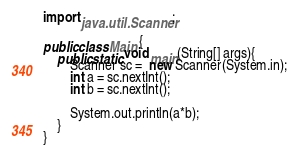<code> <loc_0><loc_0><loc_500><loc_500><_Java_>import java.util.Scanner;

public class Main {
    public static void main(String[] args){
        Scanner sc =  new Scanner(System.in);
        int a = sc.nextInt();
        int b = sc.nextInt();

        System.out.println(a*b);
    }
}
</code> 